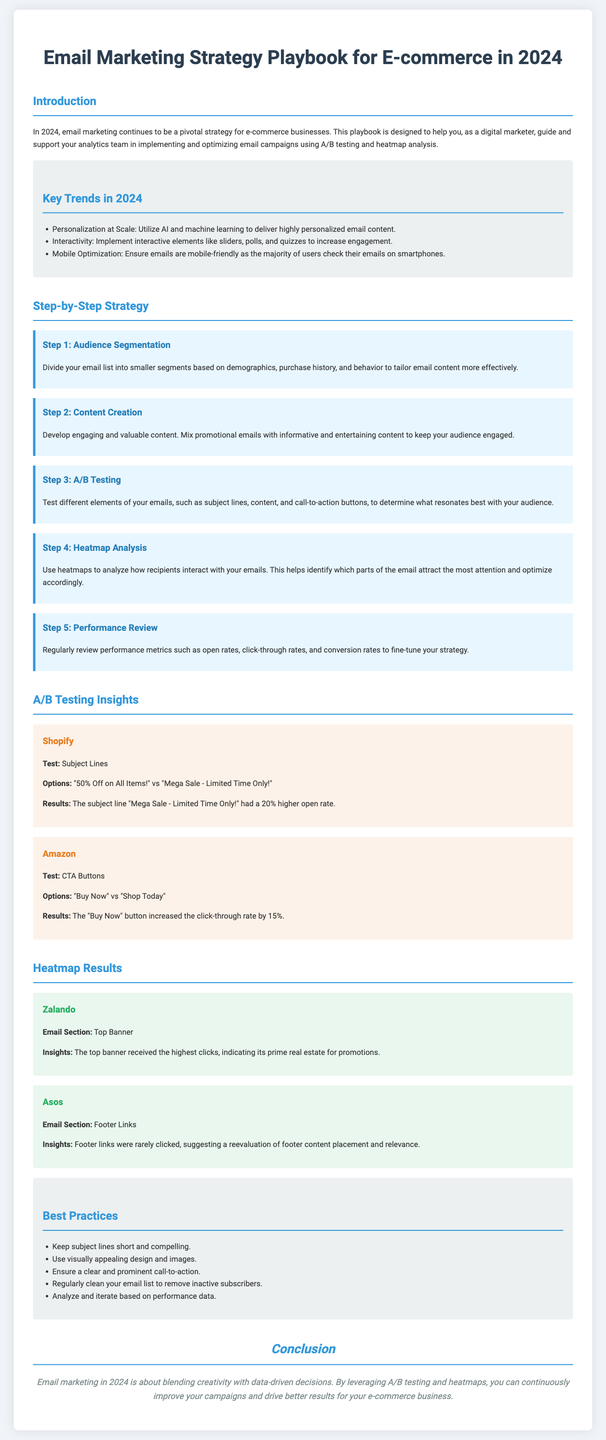What is the title of the playbook? The title is mentioned in the header section of the document.
Answer: Email Marketing Strategy Playbook for E-commerce in 2024 What is the main focus of the playbook? The introduction section outlines the focus of the playbook.
Answer: Email marketing strategy What percentage higher was the open rate for the winning subject line in Shopify's A/B test? The results of the A/B tests provide this information.
Answer: 20% Which email section received the highest clicks in Zalando's heatmap analysis? The heatmap results section identifies this detail.
Answer: Top Banner What should be included in the audience segmentation step? This step's description provides the necessary content to answer the question.
Answer: Demographics, purchase history, and behavior What is recommended to keep subject lines? This guideline can be found under best practices.
Answer: Short and compelling How many steps are included in the step-by-step strategy? The number of listed steps in the strategy section provides this answer.
Answer: 5 Which company had a heatmap analysis indicating footer links were rarely clicked? The document names the companies in their heatmap examples.
Answer: Asos What does the playbook suggest regularly cleaning? The best practices section recommends this action.
Answer: Email list 